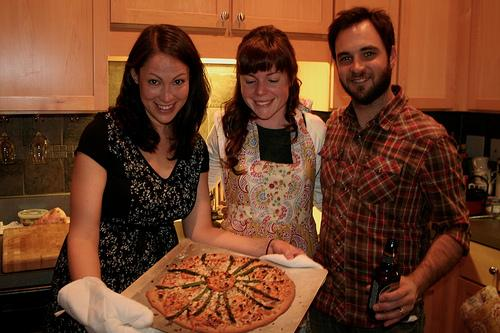How are the people feeling while holding the food?

Choices:
A) sad
B) angry
C) scared
D) proud proud 